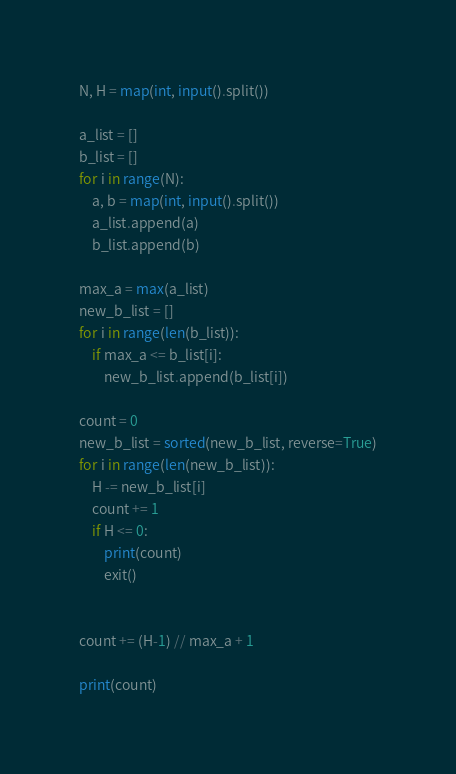<code> <loc_0><loc_0><loc_500><loc_500><_Python_>N, H = map(int, input().split())

a_list = []
b_list = []
for i in range(N):
    a, b = map(int, input().split())
    a_list.append(a)
    b_list.append(b)
    
max_a = max(a_list)
new_b_list = []
for i in range(len(b_list)):
    if max_a <= b_list[i]:
        new_b_list.append(b_list[i])
    
count = 0
new_b_list = sorted(new_b_list, reverse=True)
for i in range(len(new_b_list)):
    H -= new_b_list[i]
    count += 1
    if H <= 0:
        print(count)
        exit()


count += (H-1) // max_a + 1

print(count)</code> 